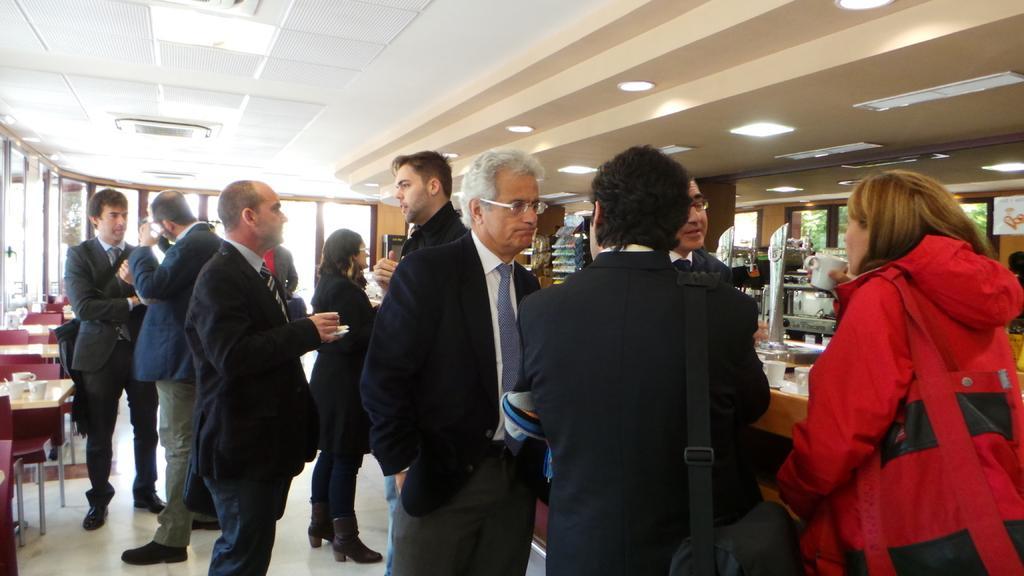In one or two sentences, can you explain what this image depicts? At the top we can see the ceiling and lights. On the right side of the picture we can see the windows. Through glass we can see green leaves. We can see a board, white cups and few objects. On the left side of the picture we can see cups, and few objects on the table. We can see the chairs. In this picture we can see the people standing on the floor. 